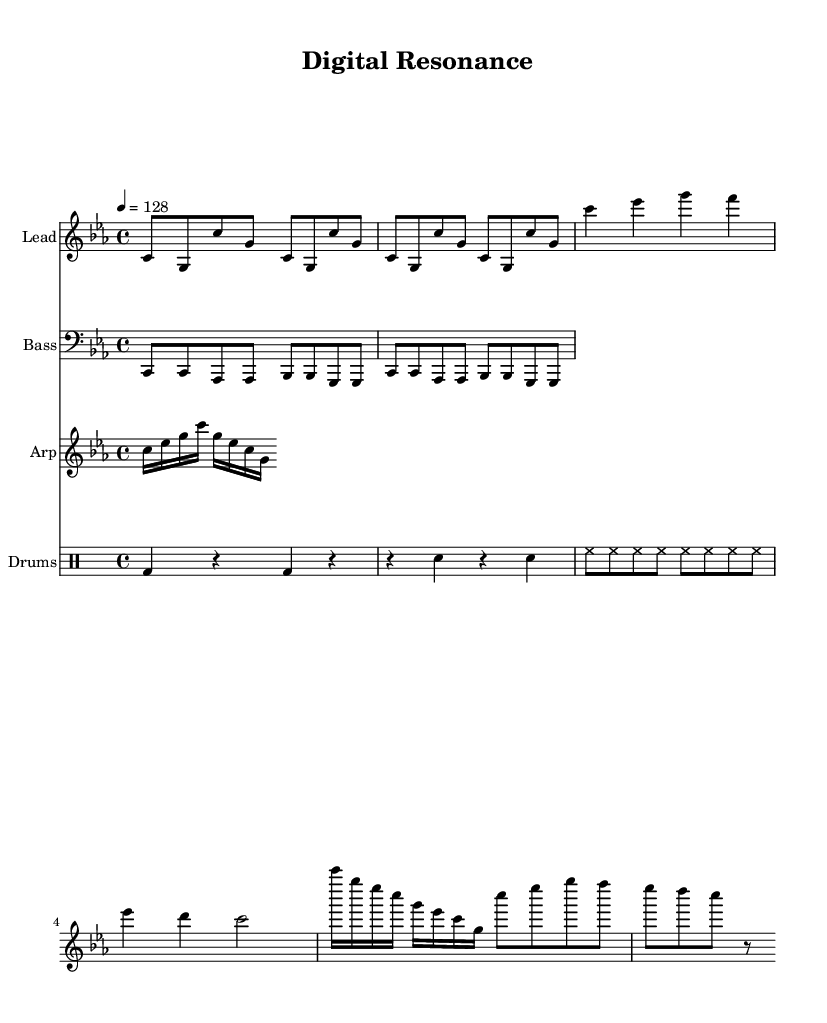What is the key signature of this music? The key signature is C minor, which has three flats (B-flat, E-flat, and A-flat). This can be identified from the key signature shown at the beginning of the sheet music.
Answer: C minor What is the time signature of this music? The time signature is 4/4, indicated at the beginning of the score. This means there are four beats per measure and a quarter note receives one beat.
Answer: 4/4 What is the tempo marking of this piece? The tempo is set at 128 beats per minute, indicated by the "4 = 128" directive at the beginning of the score. This indicates how fast the music should be played.
Answer: 128 How many measures does the verse section have? The verse section consists of two measures as shown in the written music, where specific notes are written within two distinct measures.
Answer: 2 What kind of drum pattern is featured in this track? The drum pattern features a kick, snare, and hi-hat, with specific rhythmic placements indicated in the drummode section of the sheet music. This combination is typical in house music to maintain a steady danceable beat.
Answer: Kick, Snare, Hi-hat What is the rhythm of the bassline in the first two bars? The rhythm of the bassline in the first two bars is a repeating pattern that consists of eight notes, with each note holding a quarter note value. The pattern mirrors the "c" note consistently followed by other notes.
Answer: Eight notes What is the main characteristic of the arpeggiator part? The arpeggiator part consists of sixteenth notes that follow a pattern of ascending and descending intervals, contributing to the synthetic and digital aspect of the sound, embodying the futuristic elements of house music.
Answer: Ascending and descending intervals 